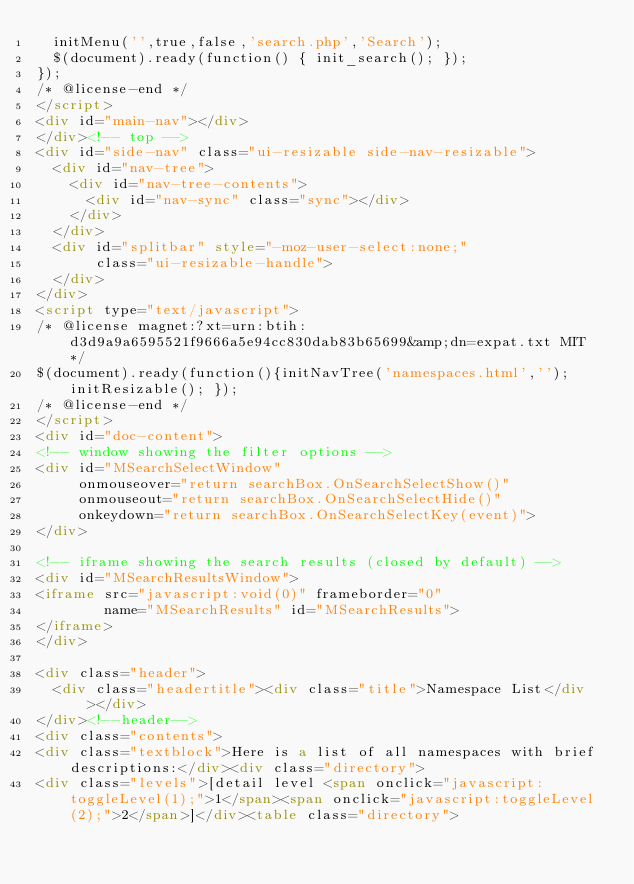Convert code to text. <code><loc_0><loc_0><loc_500><loc_500><_HTML_>  initMenu('',true,false,'search.php','Search');
  $(document).ready(function() { init_search(); });
});
/* @license-end */
</script>
<div id="main-nav"></div>
</div><!-- top -->
<div id="side-nav" class="ui-resizable side-nav-resizable">
  <div id="nav-tree">
    <div id="nav-tree-contents">
      <div id="nav-sync" class="sync"></div>
    </div>
  </div>
  <div id="splitbar" style="-moz-user-select:none;" 
       class="ui-resizable-handle">
  </div>
</div>
<script type="text/javascript">
/* @license magnet:?xt=urn:btih:d3d9a9a6595521f9666a5e94cc830dab83b65699&amp;dn=expat.txt MIT */
$(document).ready(function(){initNavTree('namespaces.html',''); initResizable(); });
/* @license-end */
</script>
<div id="doc-content">
<!-- window showing the filter options -->
<div id="MSearchSelectWindow"
     onmouseover="return searchBox.OnSearchSelectShow()"
     onmouseout="return searchBox.OnSearchSelectHide()"
     onkeydown="return searchBox.OnSearchSelectKey(event)">
</div>

<!-- iframe showing the search results (closed by default) -->
<div id="MSearchResultsWindow">
<iframe src="javascript:void(0)" frameborder="0" 
        name="MSearchResults" id="MSearchResults">
</iframe>
</div>

<div class="header">
  <div class="headertitle"><div class="title">Namespace List</div></div>
</div><!--header-->
<div class="contents">
<div class="textblock">Here is a list of all namespaces with brief descriptions:</div><div class="directory">
<div class="levels">[detail level <span onclick="javascript:toggleLevel(1);">1</span><span onclick="javascript:toggleLevel(2);">2</span>]</div><table class="directory"></code> 